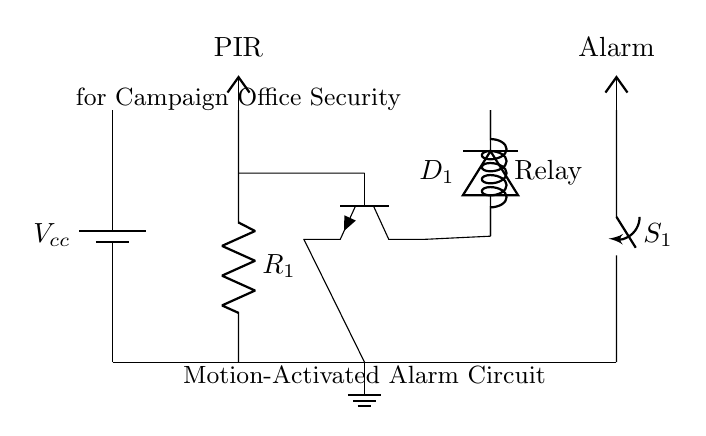What type of sensor is used in this circuit? The circuit uses a PIR (Passive Infrared) sensor, which detects motion based on changes in infrared radiation. This is visible as "PIR" in the diagram.
Answer: PIR What does the relay do in this circuit? The relay acts as a switch that is controlled by the PIR sensor through the transistor. When the sensor detects motion, it activates the relay, allowing the alarm to be turned on.
Answer: Switch What is the purpose of the resistor labeled R1? Resistor R1 is typically used to limit the current flowing into the PIR sensor. This helps to protect the circuit and ensure proper operation of the sensor.
Answer: Current limiting What happens to the alarm when motion is detected? When motion is detected, the PIR sensor sends a signal to the transistor, which activates the relay. The relay then closes the circuit to the alarm, turning it on.
Answer: Alarm activates Which component is responsible for turning the alarm on and off? The relay is responsible for turning the alarm on and off based on the signal it receives from the transistor, which is triggered by the PIR sensor.
Answer: Relay What connects the transistor to the PIR sensor in this circuit? The base of the transistor is connected directly to the output of the PIR sensor. This connection allows the sensor to control the transistor and activate the relay.
Answer: Direct connection 